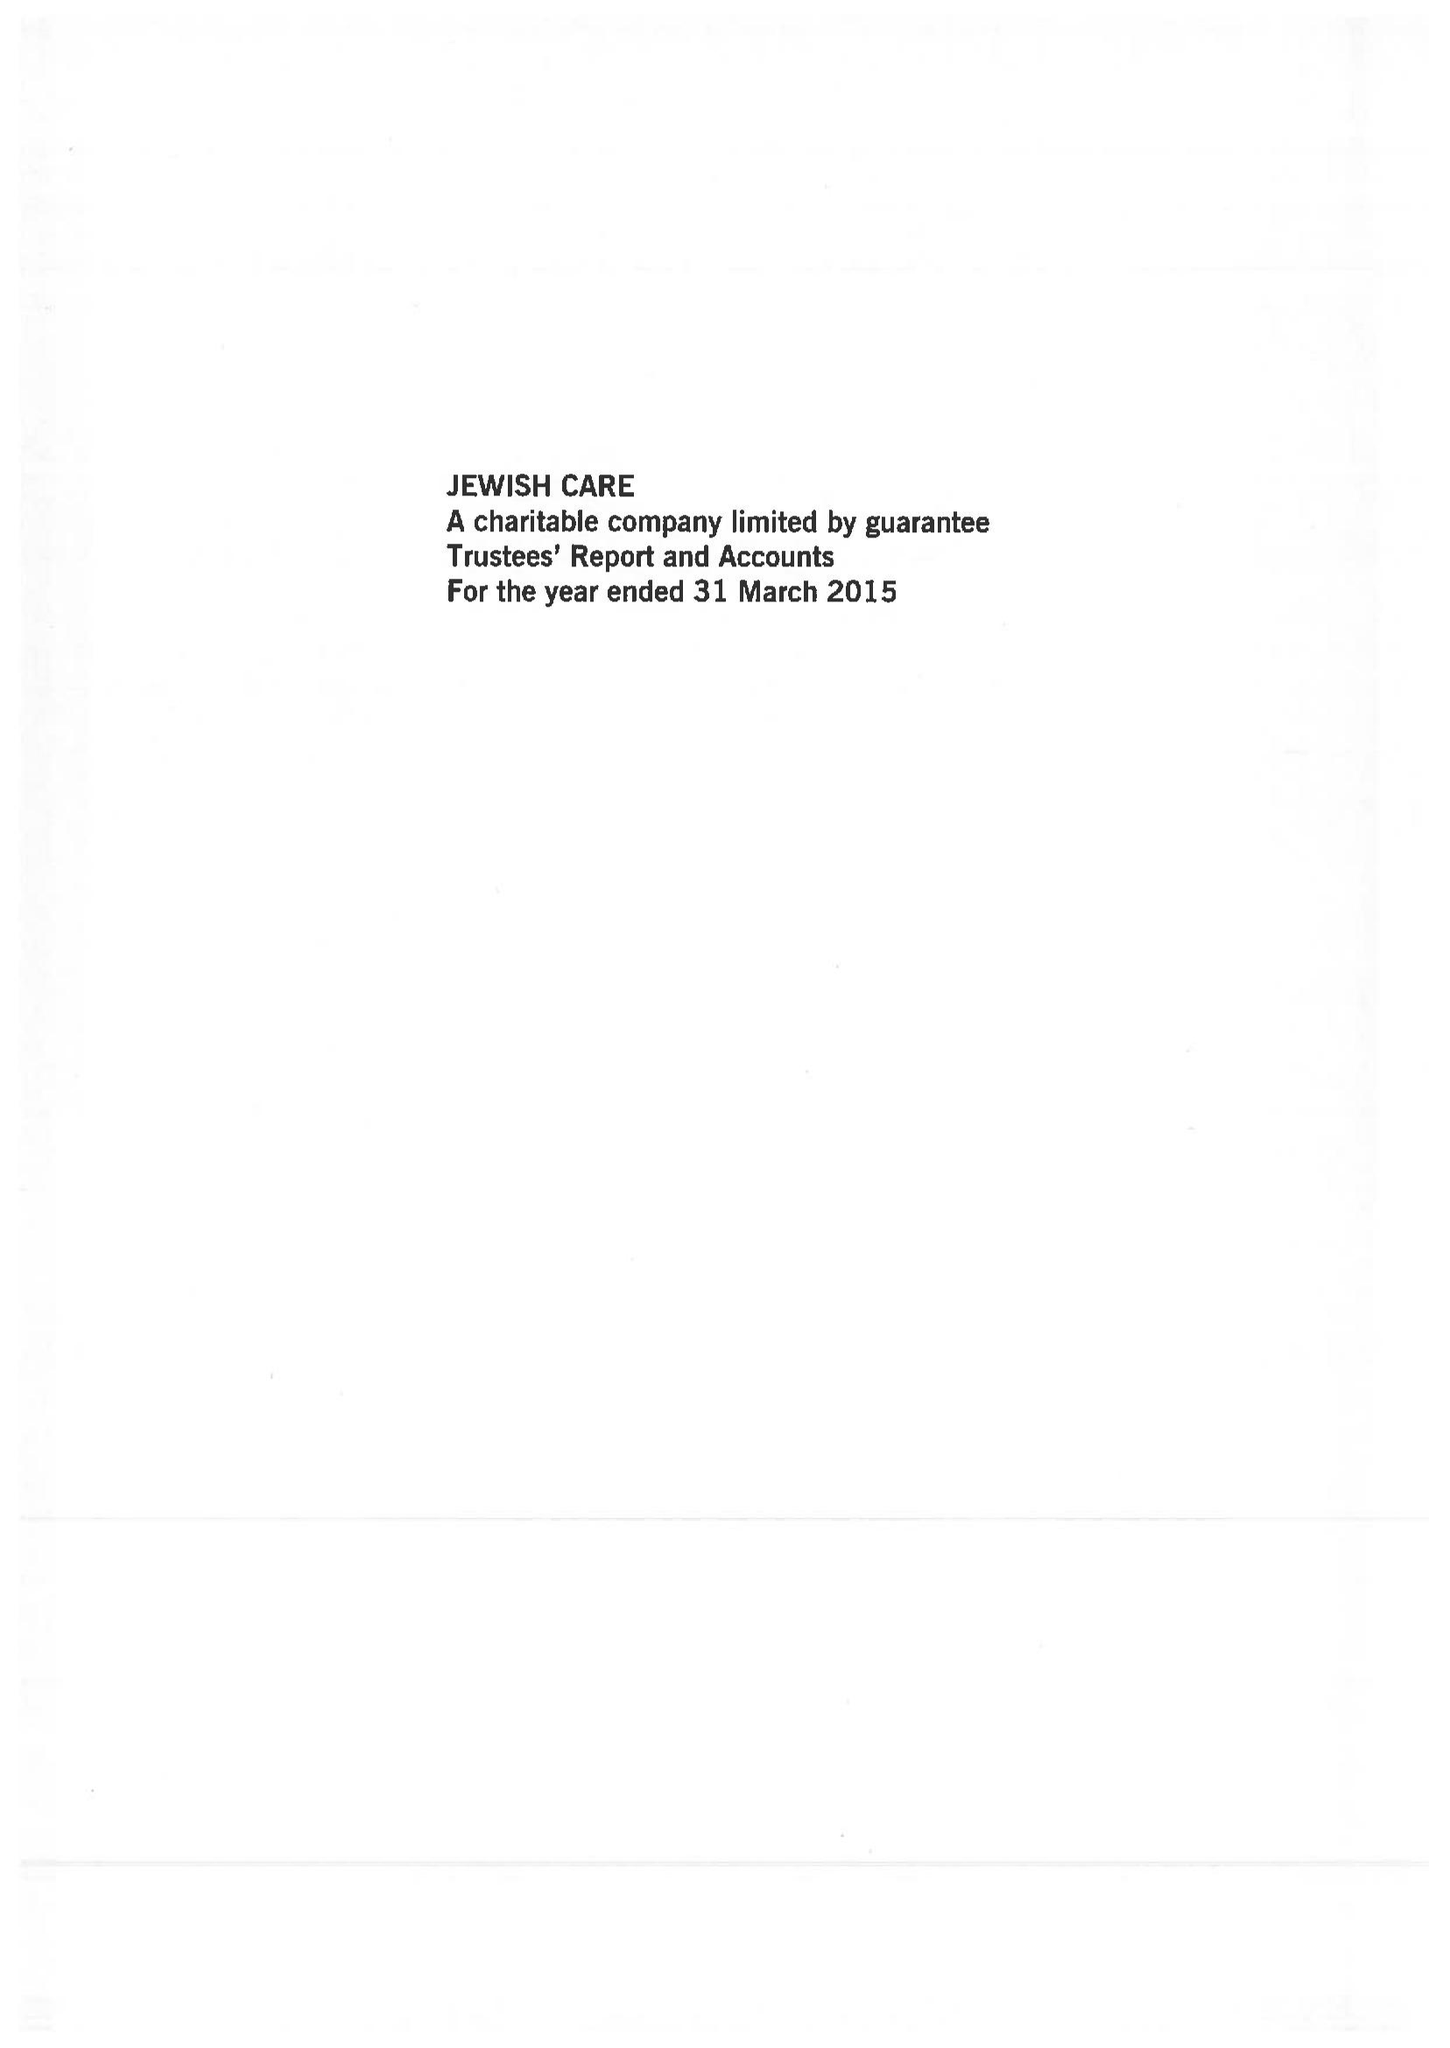What is the value for the report_date?
Answer the question using a single word or phrase. 2015-03-31 